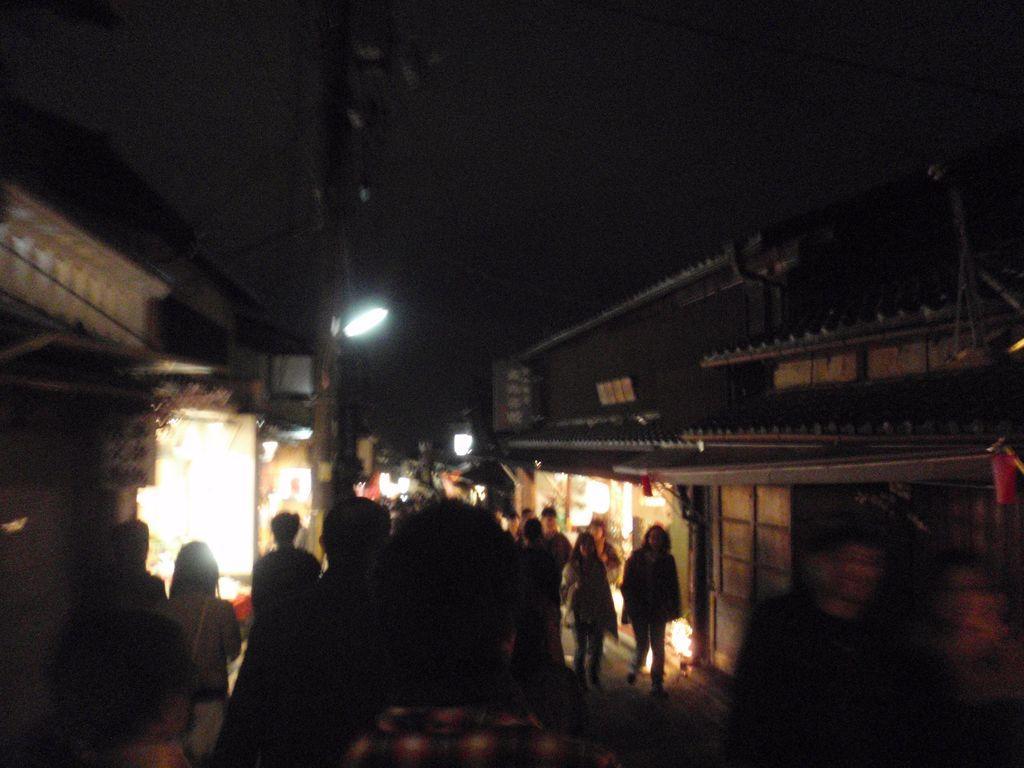Describe this image in one or two sentences. In this picture we can see a group of people on the ground, buildings, lights, poles and some objects and in the background it is dark. 